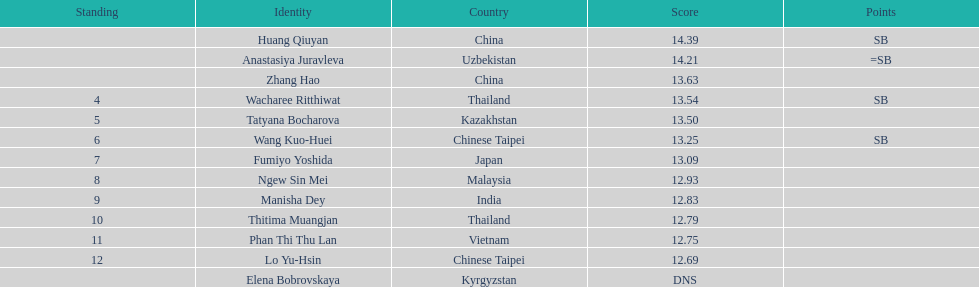How many competitors had less than 13.00 points? 6. 